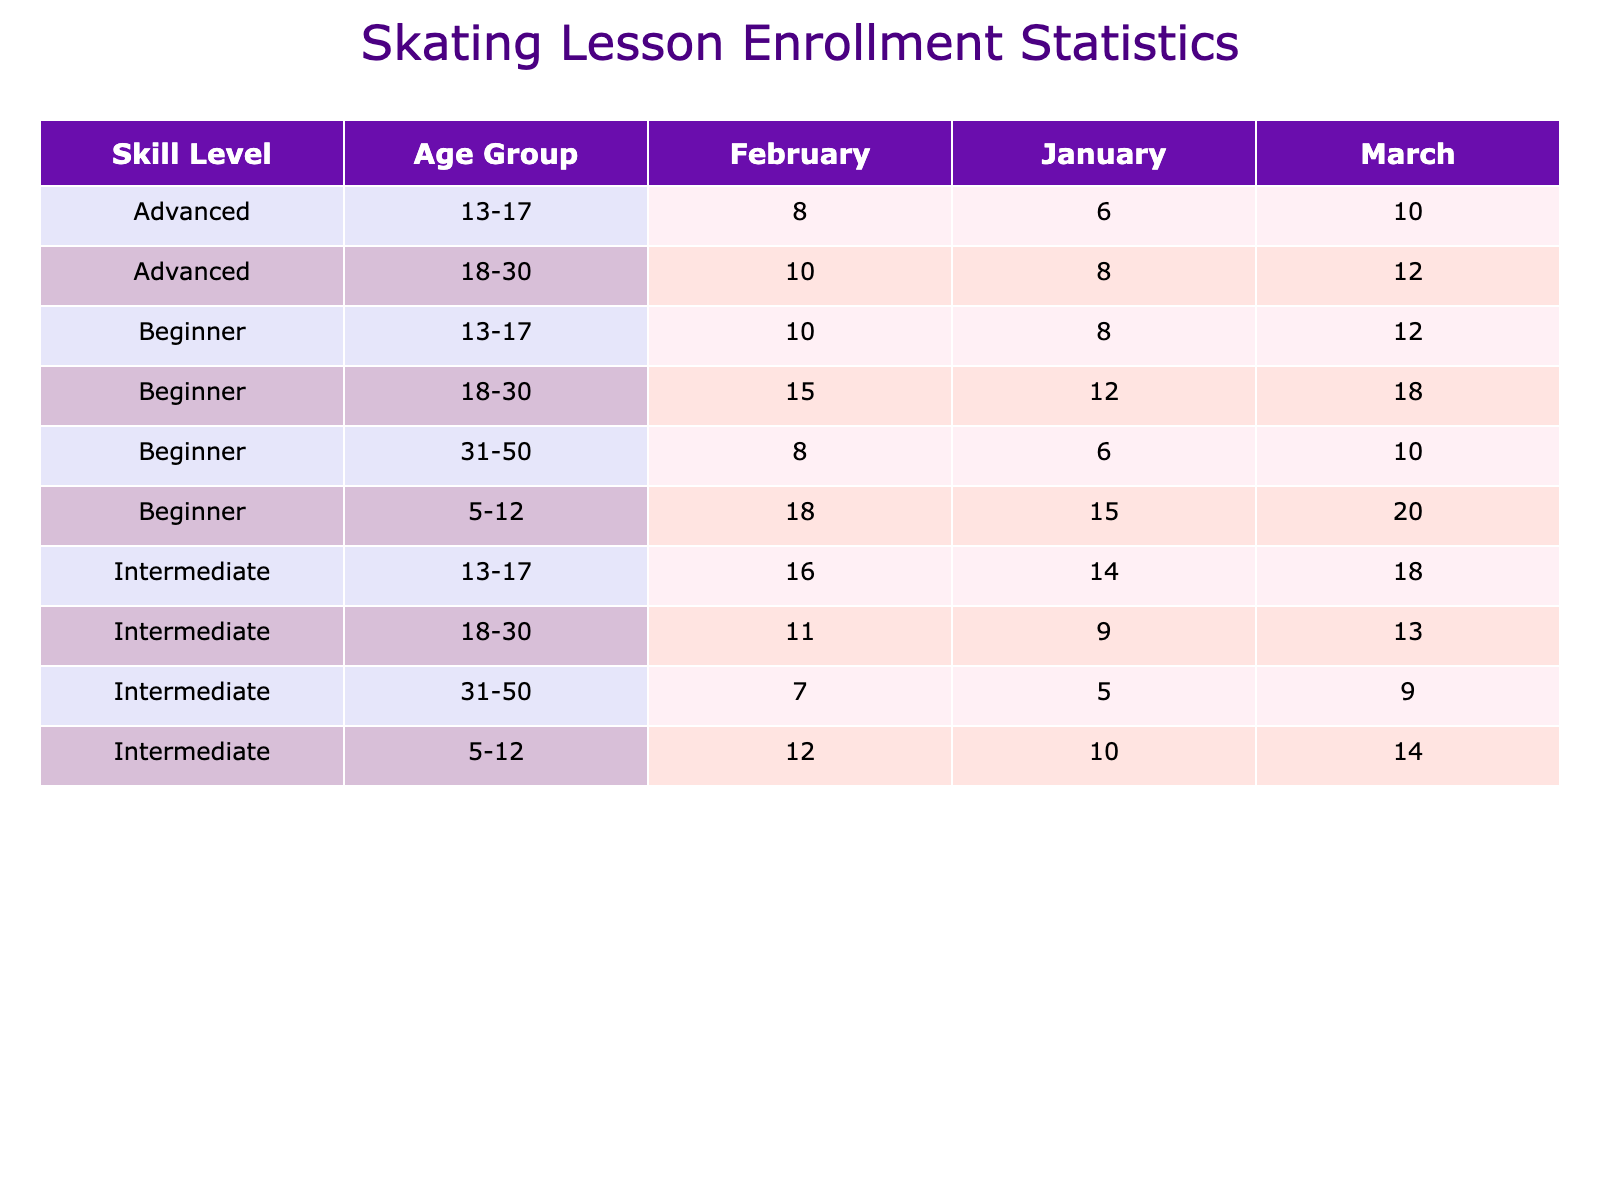What is the total enrollment count for beginner skaters aged 5-12 in March 2023? In March 2023, the table shows that there are 20 enrollments for beginner skaters aged 5-12. Therefore, the total count is simply taken from this cell.
Answer: 20 How many students enrolled in intermediate skating classes aged 18-30 in February 2023? The table indicates that in February 2023, the enrollment count for intermediate skaters aged 18-30 is 11. We find this value directly in the relevant cell of the table.
Answer: 11 Which age group had the highest enrollment for advanced skaters in January 2023? In January 2023, the table indicates that the ages 13-17 had 6 enrollments and 18-30 had 8 enrollments, while the other groups had none. Thus, the age group with the highest enrollment for advanced skaters is 18-30.
Answer: 18-30 What is the total enrollment for intermediate skaters across all age groups in March 2023? In March 2023, we sum the enrollment counts for intermediate skaters across all age groups: 14 (5-12) + 18 (13-17) + 13 (18-30) + 9 (31-50) = 54. The total is obtained by adding these values together.
Answer: 54 Did the number of beginner skaters aged 13-17 increase from January to March 2023? In January 2023, the enrollment count for beginner skaters aged 13-17 was 8, while in March 2023, it was 12. Since 12 is greater than 8, we conclude that there was an increase in enrollment.
Answer: Yes What is the average enrollment for advanced skaters aged 13-17 across all recorded months? The table shows 6 enrollments in January and 8 in February, and 10 in March for advanced skaters aged 13-17. To find the average, we sum these counts (6 + 8 + 10 = 24) and then divide by the number of months (3). Thus, the average is 24 / 3 = 8.
Answer: 8 How many more beginner skaters aged 5-12 enrolled in February 2023 compared to January 2023? From the table, in January 2023, there were 15 enrollments for beginner skaters aged 5-12 and in February 2023, there were 18. The difference is calculated as 18 - 15 = 3.
Answer: 3 Which instructor had the highest total enrollment across all skill levels and age groups in January 2023? We need to check the enrollment numbers for each instructor. Sarah Johnson had 15 (5-12) + 8 (13-17) = 23. Michael Lee had 12 (18-30) + 6 (31-50) = 18. Emily Chen had 10 (5-12) + 14 (13-17) + 9 (18-30) + 5 (31-50) = 38. David Brown had 9 + 5 = 14, and Anna Petrova had 6 + 8 = 14. Thus, Emily Chen had the highest total of 38.
Answer: Emily Chen What percentage of the total enrollment for beginner skaters aged 31-50 in February 2023 compared to the total enrollment for the same age group across all months? For beginner skaters aged 31-50, in February 2023, total enrollment was 8. The total for this group across all months: January (6) + February (8) + March (10) = 24. The percentage is calculated as (8 / 24) * 100 = 33.33%.
Answer: 33.33% 